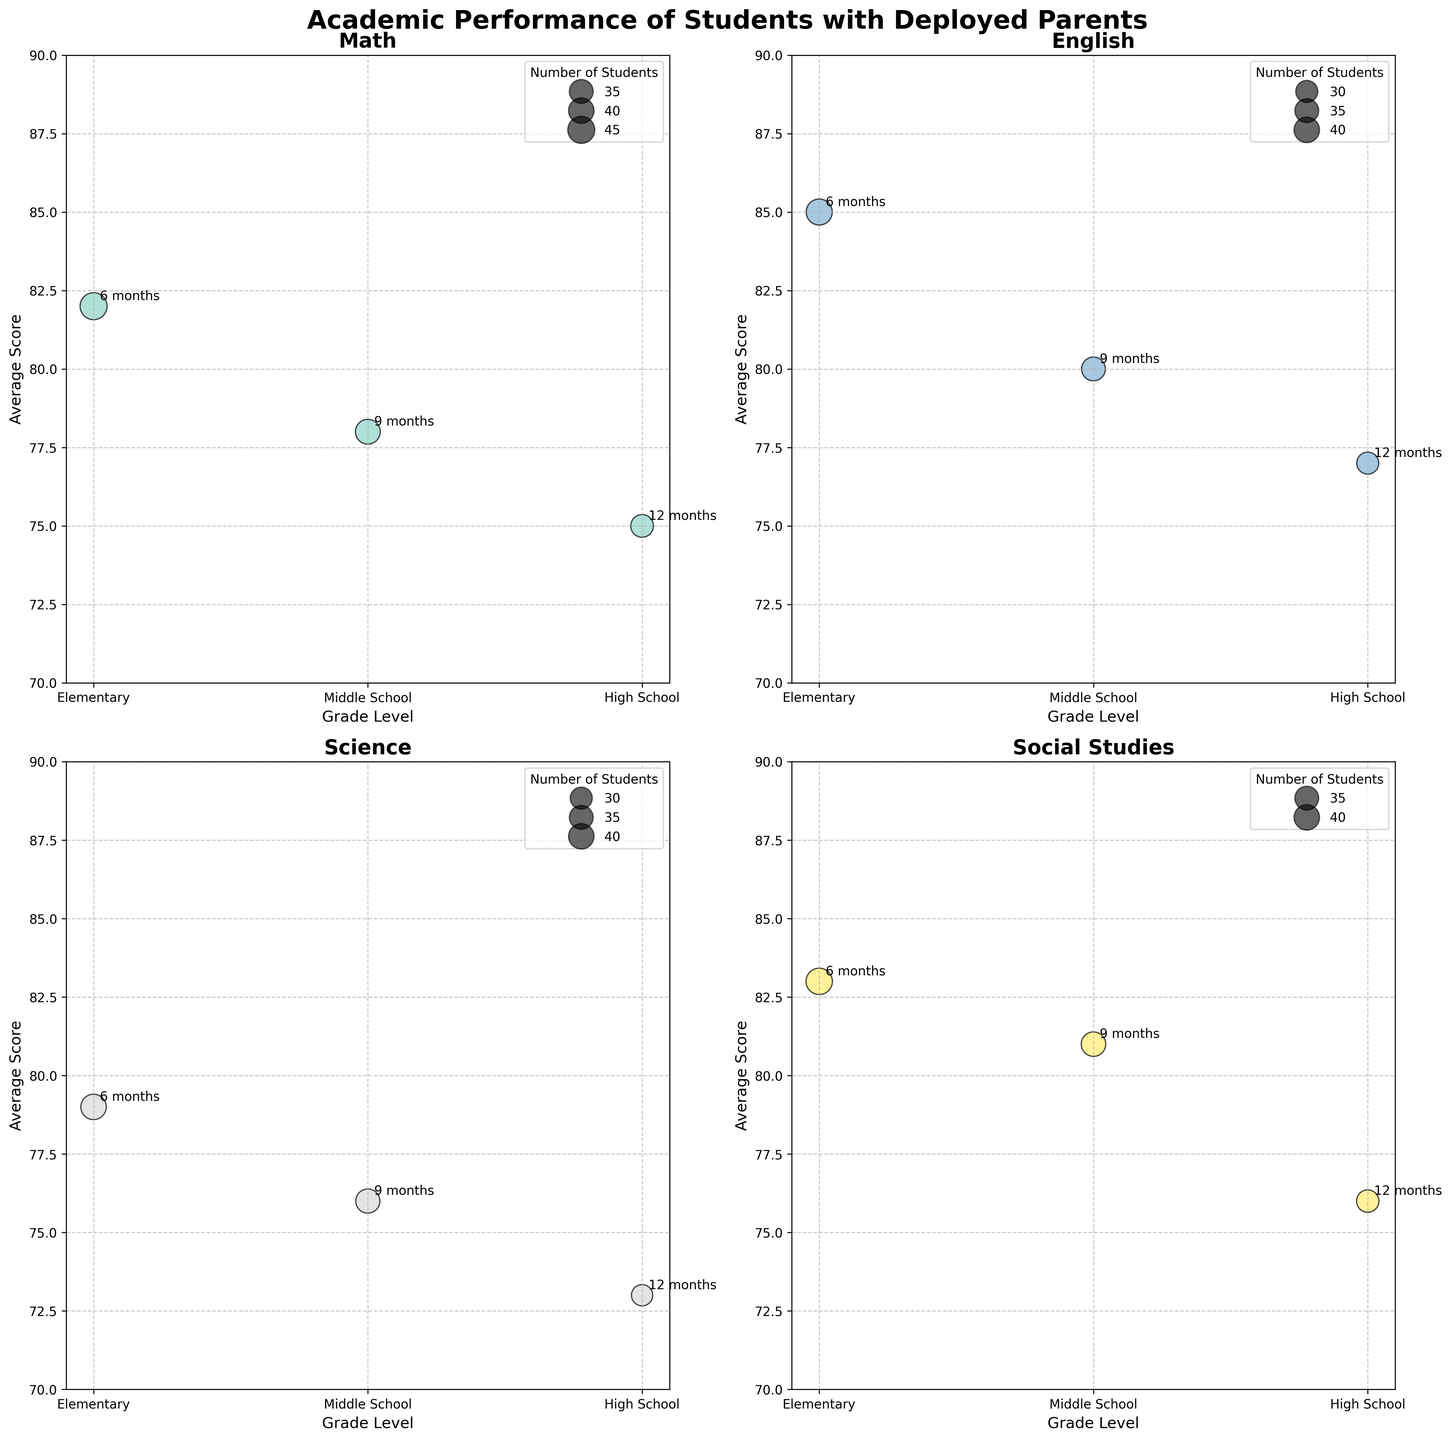What is the title of the figure? The title is located at the top of the figure. It usually gives a summary of what the plot is about. The title here is "Academic Performance of Students with Deployed Parents".
Answer: Academic Performance of Students with Deployed Parents What does the y-axis represent in the created plot? The y-axis represents the average scores of the students. The range of the scores is from 70 to 90.
Answer: Average Scores How many subject areas are shown in the figure? The subplot includes four different subject areas: Math, English, Science, and Social Studies. Each subject has its own subplot to display the data.
Answer: 4 How long is the parent deployment for High School students who study Math? The High School bubble in the Math subplot has a label annotating the deployment length. It shows "12 months" beside the bubble representing High School students.
Answer: 12 months What is the average score of Elementary students in Science? Look at the bubble that represents Elementary grade level in the Science subplot. The y-axis value for this bubble is 79.
Answer: 79 Which subject has the highest average score for Elementary students? Check each subplot for the Elementary bubbles and compare their y-axis values. English has the highest score with an average of 85.
Answer: English Which grade level generally has the lowest average scores across all subjects? Assess each subplot and compare the average scores across all subjects for different grade levels. High School grade level has the lowest average scores in Math (75), English (77), Science (73), and Social Studies (76).
Answer: High School Which subjects have larger bubbles for Middle School compared to High School? Compare the size of the bubbles in each subplot for Middle School and High School. Math and Social Studies have larger bubbles for Middle School than High School, indicating more students in Middle School for those subjects.
Answer: Math, Social Studies Is there any subject where the average score decreases as the grade level increases? Analyze the trends in average scores within each subplot. In each subject (Math, English, Science, Social Studies), the average scores tend to decrease as the grade level increases from Elementary to High School.
Answer: Yes, all subjects What is the average number of students in the Middle School grade level across all subjects? Total the number of students for Middle School in each subject. Math has 38 students, English has 35, Science has 36, and Social Studies has 37. The calculation is (38 + 35 + 36 + 37) / 4. This averages to 36.5 students.
Answer: 36.5 